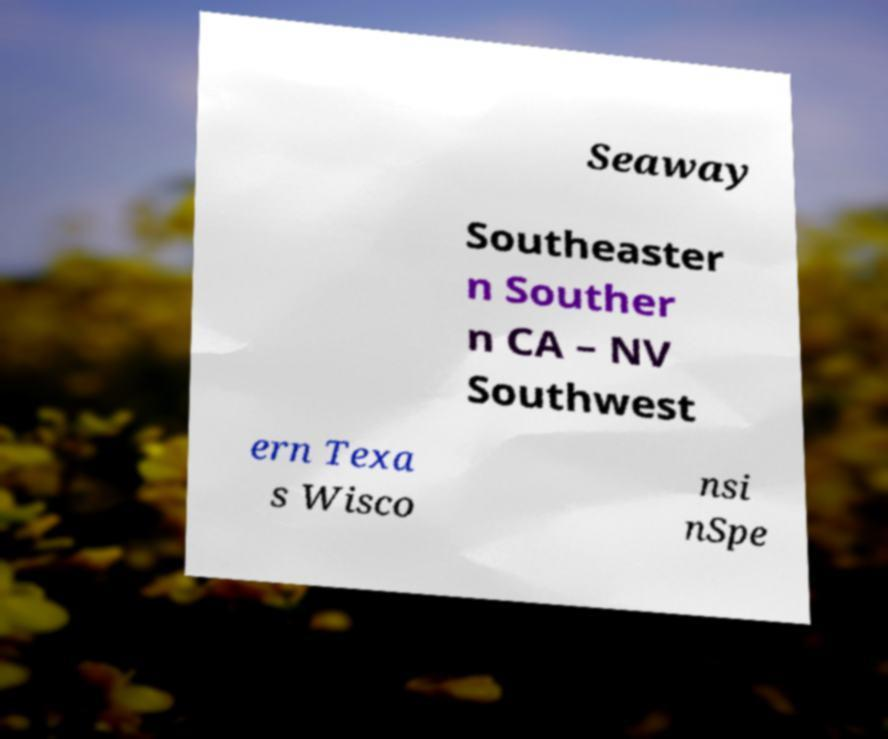Can you read and provide the text displayed in the image?This photo seems to have some interesting text. Can you extract and type it out for me? Seaway Southeaster n Souther n CA – NV Southwest ern Texa s Wisco nsi nSpe 